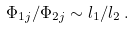<formula> <loc_0><loc_0><loc_500><loc_500>\Phi _ { 1 j } / \Phi _ { 2 j } \sim l _ { 1 } / l _ { 2 } \, .</formula> 